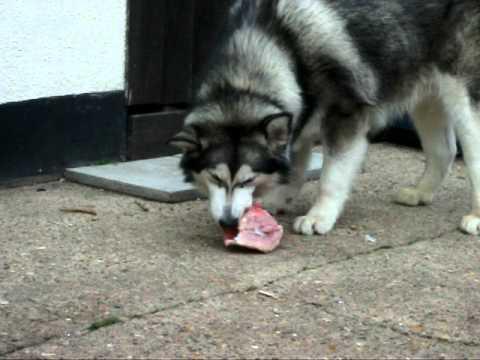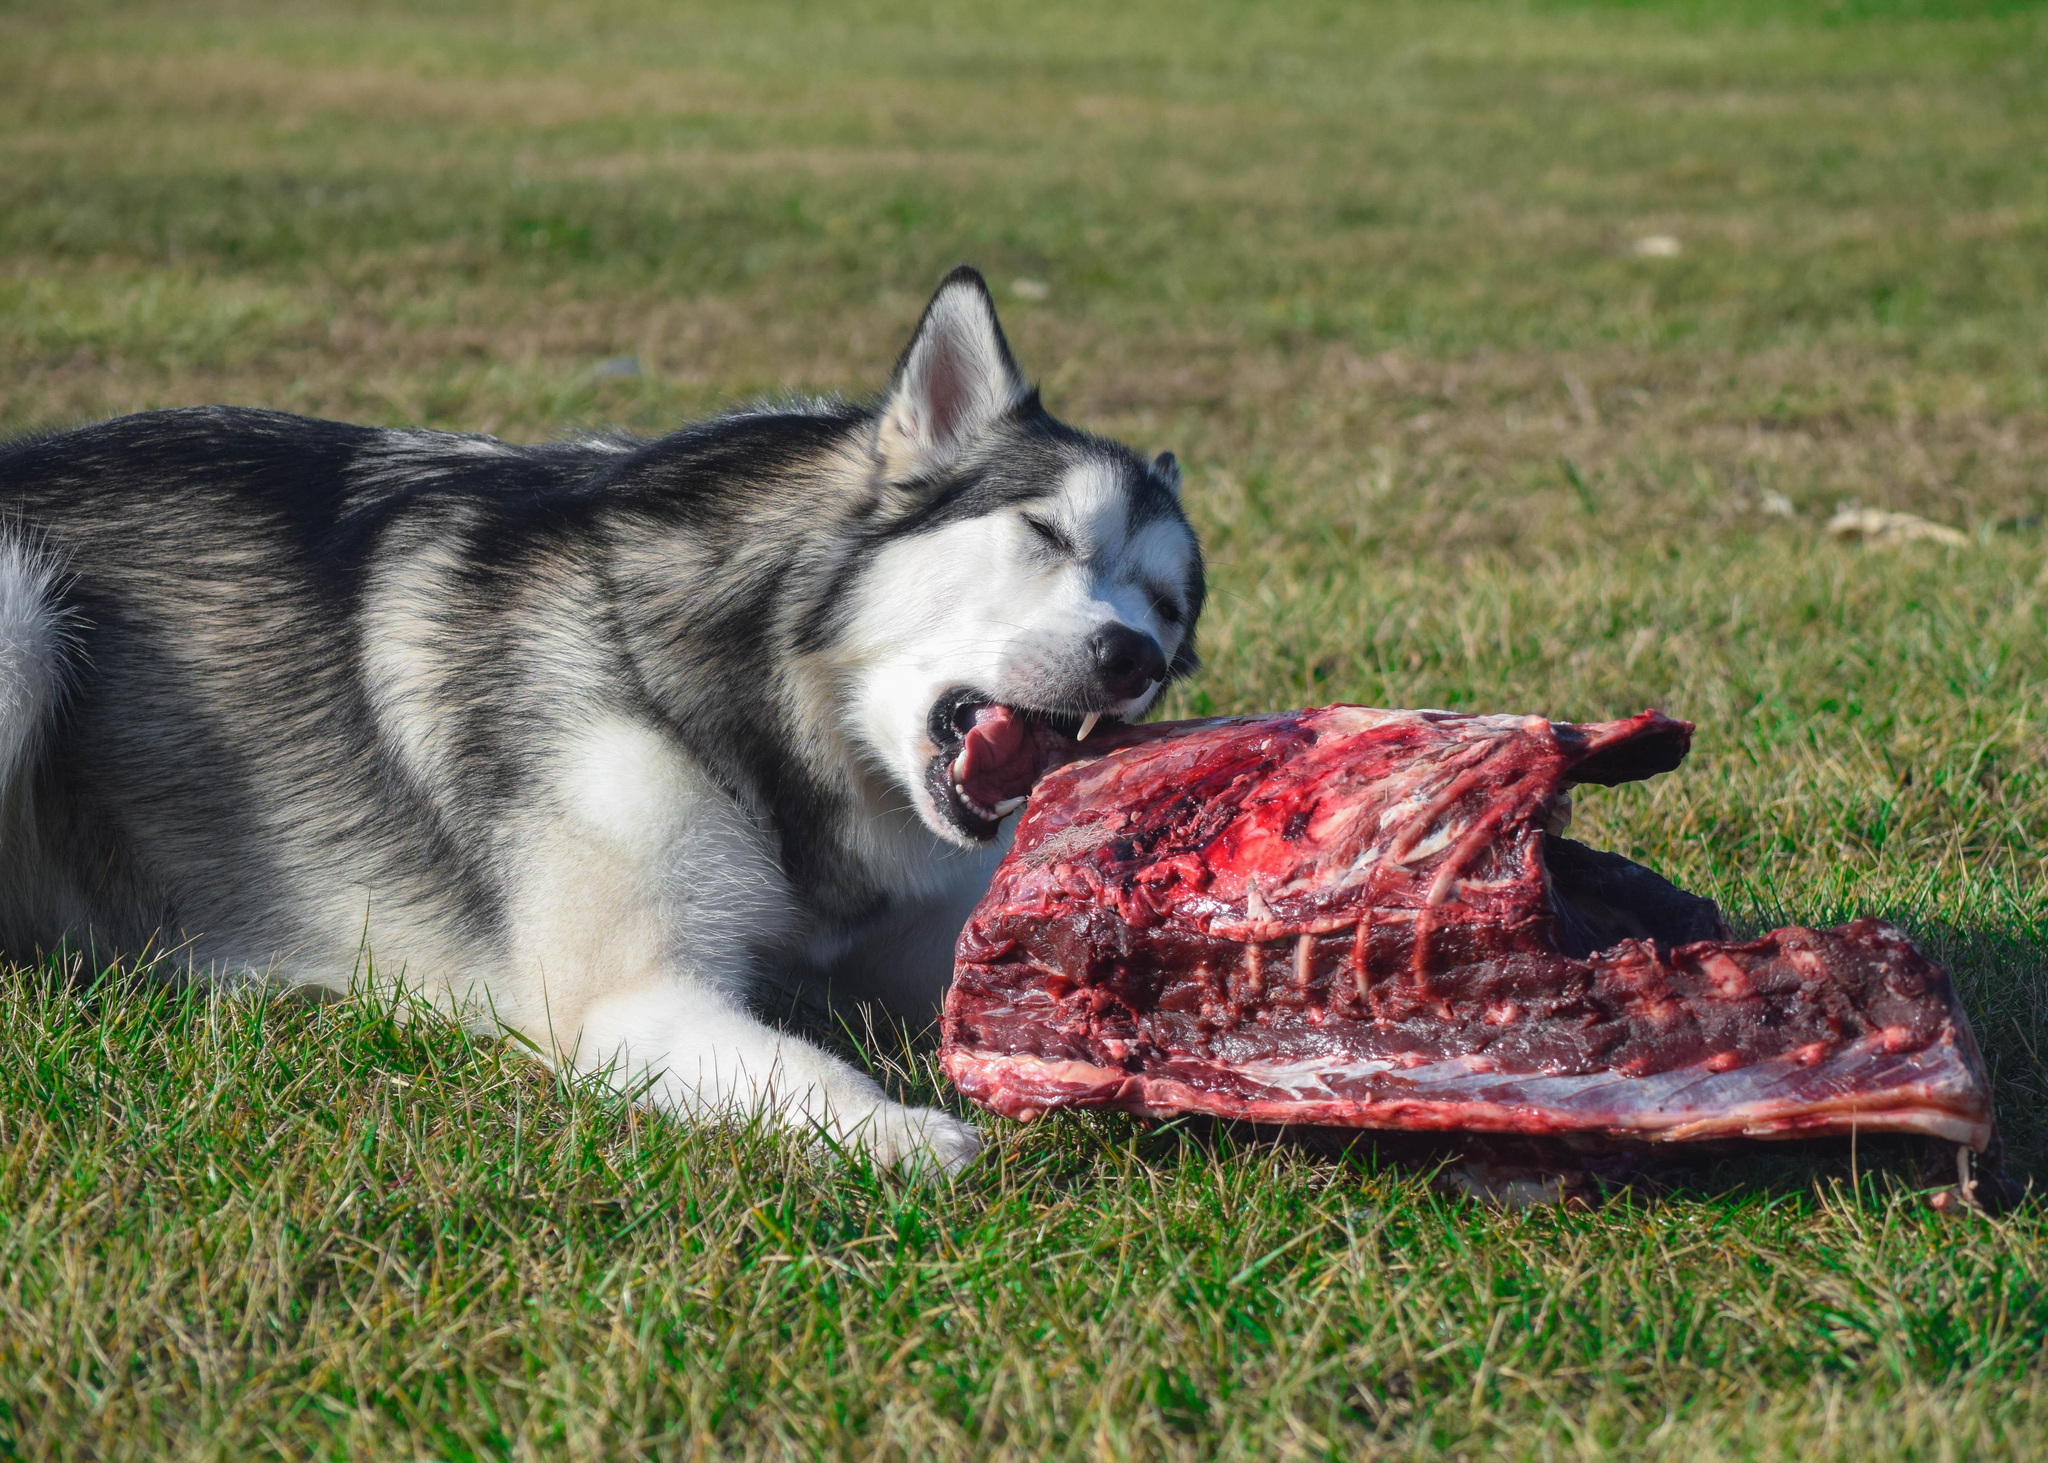The first image is the image on the left, the second image is the image on the right. Considering the images on both sides, is "The dog in the image on the right is indoors." valid? Answer yes or no. No. The first image is the image on the left, the second image is the image on the right. For the images displayed, is the sentence "Each image contains just one dog, all dogs are black-and-white husky types, and the dog on the right is reclining with extended front paws." factually correct? Answer yes or no. Yes. 